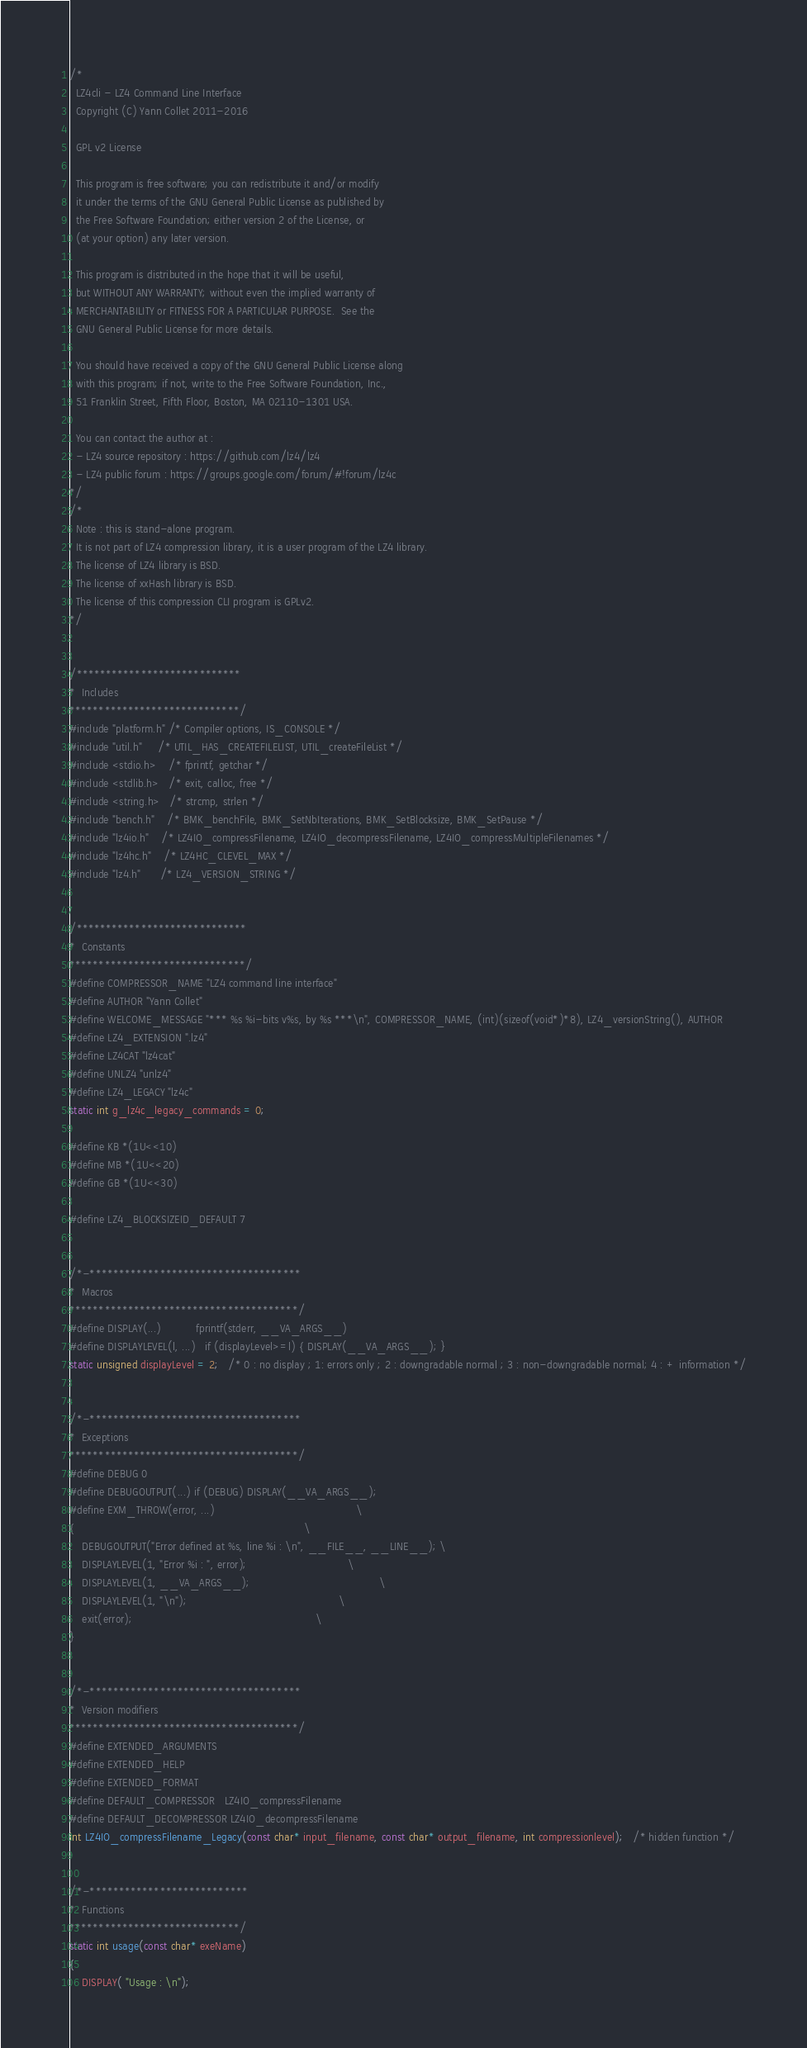Convert code to text. <code><loc_0><loc_0><loc_500><loc_500><_C_>/*
  LZ4cli - LZ4 Command Line Interface
  Copyright (C) Yann Collet 2011-2016

  GPL v2 License

  This program is free software; you can redistribute it and/or modify
  it under the terms of the GNU General Public License as published by
  the Free Software Foundation; either version 2 of the License, or
  (at your option) any later version.

  This program is distributed in the hope that it will be useful,
  but WITHOUT ANY WARRANTY; without even the implied warranty of
  MERCHANTABILITY or FITNESS FOR A PARTICULAR PURPOSE.  See the
  GNU General Public License for more details.

  You should have received a copy of the GNU General Public License along
  with this program; if not, write to the Free Software Foundation, Inc.,
  51 Franklin Street, Fifth Floor, Boston, MA 02110-1301 USA.

  You can contact the author at :
  - LZ4 source repository : https://github.com/lz4/lz4
  - LZ4 public forum : https://groups.google.com/forum/#!forum/lz4c
*/
/*
  Note : this is stand-alone program.
  It is not part of LZ4 compression library, it is a user program of the LZ4 library.
  The license of LZ4 library is BSD.
  The license of xxHash library is BSD.
  The license of this compression CLI program is GPLv2.
*/


/****************************
*  Includes
*****************************/
#include "platform.h" /* Compiler options, IS_CONSOLE */
#include "util.h"     /* UTIL_HAS_CREATEFILELIST, UTIL_createFileList */
#include <stdio.h>    /* fprintf, getchar */
#include <stdlib.h>   /* exit, calloc, free */
#include <string.h>   /* strcmp, strlen */
#include "bench.h"    /* BMK_benchFile, BMK_SetNbIterations, BMK_SetBlocksize, BMK_SetPause */
#include "lz4io.h"    /* LZ4IO_compressFilename, LZ4IO_decompressFilename, LZ4IO_compressMultipleFilenames */
#include "lz4hc.h"    /* LZ4HC_CLEVEL_MAX */
#include "lz4.h"      /* LZ4_VERSION_STRING */


/*****************************
*  Constants
******************************/
#define COMPRESSOR_NAME "LZ4 command line interface"
#define AUTHOR "Yann Collet"
#define WELCOME_MESSAGE "*** %s %i-bits v%s, by %s ***\n", COMPRESSOR_NAME, (int)(sizeof(void*)*8), LZ4_versionString(), AUTHOR
#define LZ4_EXTENSION ".lz4"
#define LZ4CAT "lz4cat"
#define UNLZ4 "unlz4"
#define LZ4_LEGACY "lz4c"
static int g_lz4c_legacy_commands = 0;

#define KB *(1U<<10)
#define MB *(1U<<20)
#define GB *(1U<<30)

#define LZ4_BLOCKSIZEID_DEFAULT 7


/*-************************************
*  Macros
***************************************/
#define DISPLAY(...)           fprintf(stderr, __VA_ARGS__)
#define DISPLAYLEVEL(l, ...)   if (displayLevel>=l) { DISPLAY(__VA_ARGS__); }
static unsigned displayLevel = 2;   /* 0 : no display ; 1: errors only ; 2 : downgradable normal ; 3 : non-downgradable normal; 4 : + information */


/*-************************************
*  Exceptions
***************************************/
#define DEBUG 0
#define DEBUGOUTPUT(...) if (DEBUG) DISPLAY(__VA_ARGS__);
#define EXM_THROW(error, ...)                                             \
{                                                                         \
    DEBUGOUTPUT("Error defined at %s, line %i : \n", __FILE__, __LINE__); \
    DISPLAYLEVEL(1, "Error %i : ", error);                                \
    DISPLAYLEVEL(1, __VA_ARGS__);                                         \
    DISPLAYLEVEL(1, "\n");                                                \
    exit(error);                                                          \
}


/*-************************************
*  Version modifiers
***************************************/
#define EXTENDED_ARGUMENTS
#define EXTENDED_HELP
#define EXTENDED_FORMAT
#define DEFAULT_COMPRESSOR   LZ4IO_compressFilename
#define DEFAULT_DECOMPRESSOR LZ4IO_decompressFilename
int LZ4IO_compressFilename_Legacy(const char* input_filename, const char* output_filename, int compressionlevel);   /* hidden function */


/*-***************************
*  Functions
*****************************/
static int usage(const char* exeName)
{
    DISPLAY( "Usage : \n");</code> 